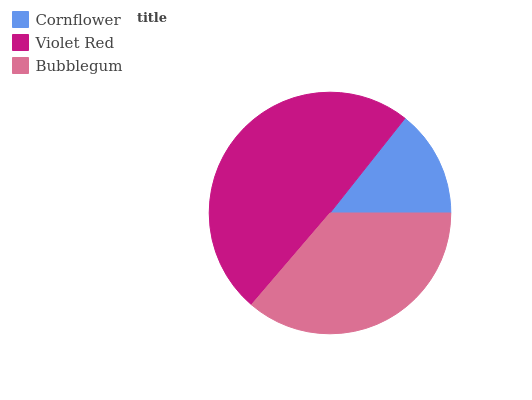Is Cornflower the minimum?
Answer yes or no. Yes. Is Violet Red the maximum?
Answer yes or no. Yes. Is Bubblegum the minimum?
Answer yes or no. No. Is Bubblegum the maximum?
Answer yes or no. No. Is Violet Red greater than Bubblegum?
Answer yes or no. Yes. Is Bubblegum less than Violet Red?
Answer yes or no. Yes. Is Bubblegum greater than Violet Red?
Answer yes or no. No. Is Violet Red less than Bubblegum?
Answer yes or no. No. Is Bubblegum the high median?
Answer yes or no. Yes. Is Bubblegum the low median?
Answer yes or no. Yes. Is Cornflower the high median?
Answer yes or no. No. Is Violet Red the low median?
Answer yes or no. No. 